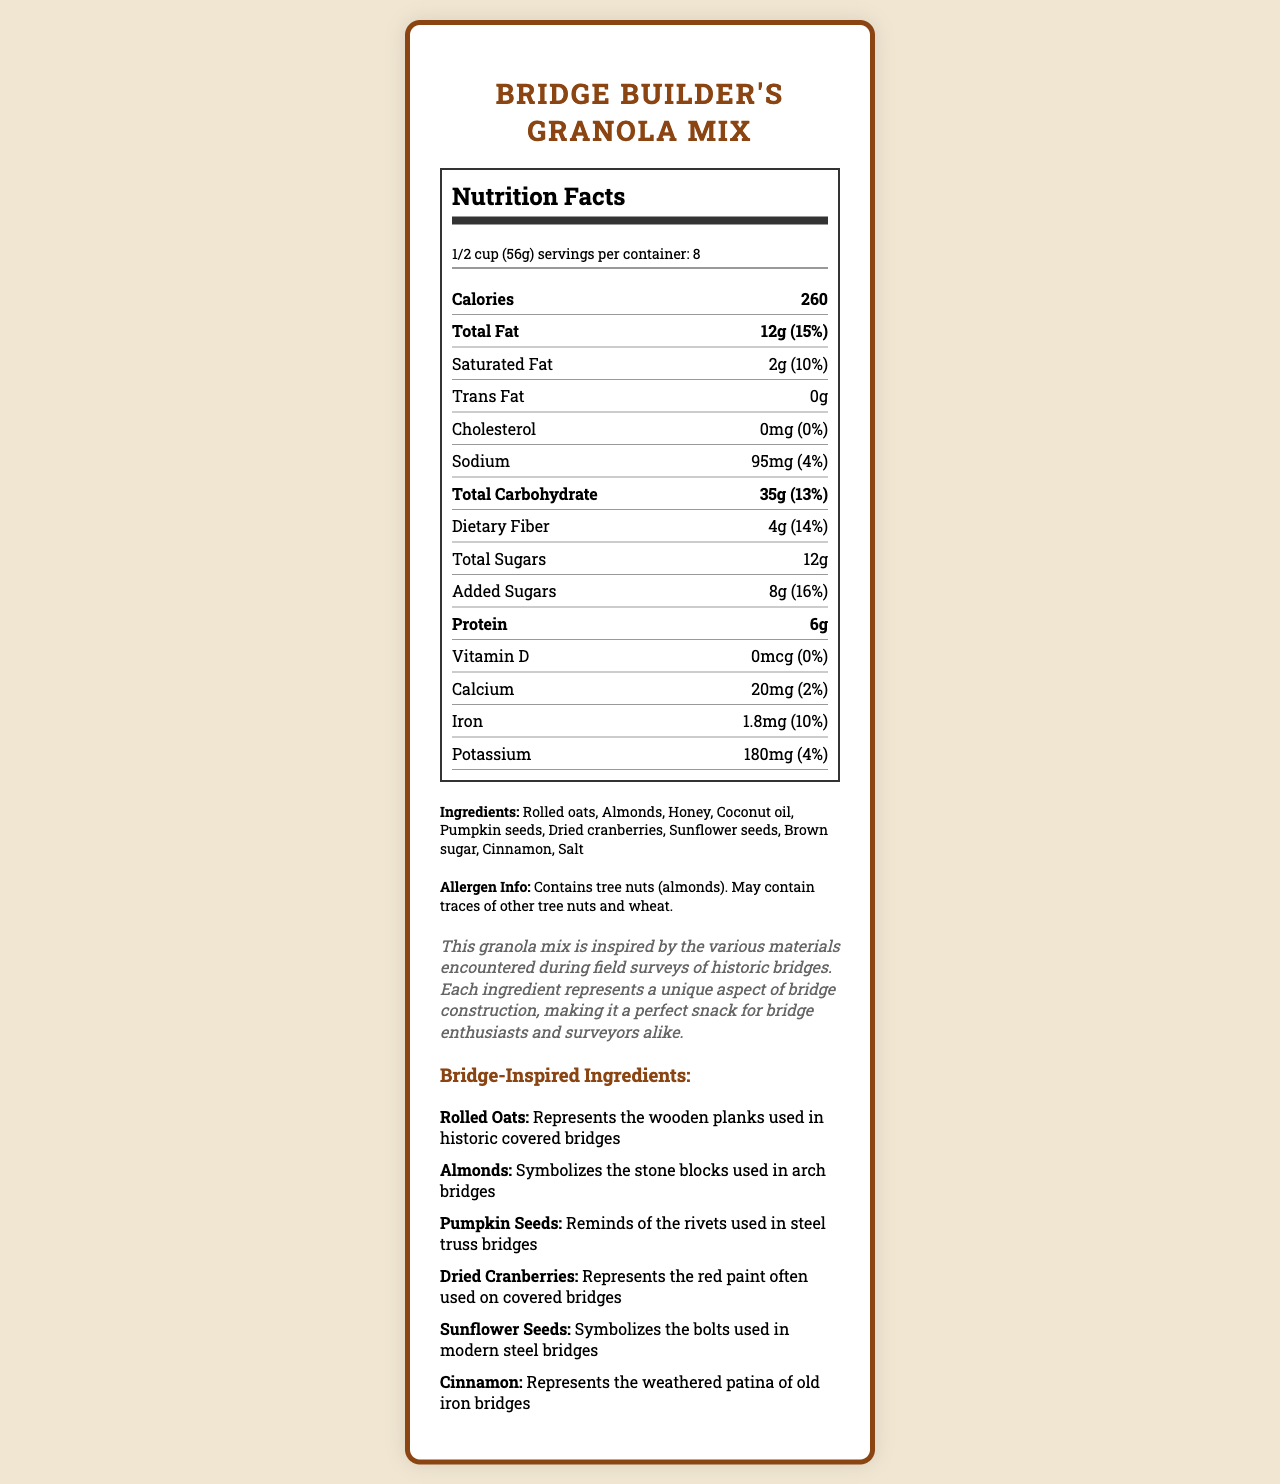what is the serving size for Bridge Builder's Granola Mix? The document states the serving size directly under the product name and serving info section: "1/2 cup (56g)".
Answer: 1/2 cup (56g) how many servings are in the container? The document specifies "servings per container" as 8.
Answer: 8 what ingredient represents the wooden planks used in historic covered bridges? According to the bridge-inspired ingredients section, rolled oats represent the wooden planks used in historic covered bridges.
Answer: Rolled oats how much protein is in one serving of the granola mix? The nutrition label shows "Protein: 6g" under the nutrient section.
Answer: 6g what percentage of the daily value for total fat does one serving of the granola mix provide? The document lists total fat as "12g (15%)".
Answer: 15% how much dietary fiber does the Bridge Builder's Granola Mix contain per serving? The document shows dietary fiber as 4g per serving.
Answer: 4g what specific ingredient symbolizes the stone blocks used in arch bridges? The bridge-inspired ingredients section states that almonds symbolize the stone blocks used in arch bridges.
Answer: Almonds how many milligrams of potassium does one serving of granola mix contain? The nutrition label lists potassium as 180mg per serving.
Answer: 180mg what is the amount of saturated fat per serving and its percentage of daily value? The document lists saturated fat as "2g (10%)".
Answer: 2g, 10% is there any cholesterol in the granola mix? The nutrition label indicates "Cholesterol: 0mg (0%)".
Answer: No what is the granola mix inspired by, according to the bridge surveyor note? The bridge surveyor note explains that each ingredient represents a unique aspect of bridge construction inspired by historic bridges, making it a perfect snack for bridge enthusiasts and surveyors.
Answer: Historic bridges and the materials encountered during field surveys what are the main ingredients used in the Bridge Builder's Granola Mix? These ingredients are listed under the ingredients section.
Answer: Rolled oats, almonds, honey, coconut oil, pumpkin seeds, dried cranberries, sunflower seeds, brown sugar, cinnamon, salt what historical bridge element do pumpkin seeds symbolize? The bridge-inspired ingredients section describes pumpkin seeds as reminding of the rivets used in steel truss bridges.
Answer: Rivets used in steel truss bridges what is the main idea of the document? The document includes detailed nutritional facts, a list of ingredients, allergen information, and an explanation of how each ingredient represents different bridge construction materials.
Answer: The document provides nutritional and ingredient information for Bridge Builder's Granola Mix, a snack inspired by various materials used in historic bridge construction, making it appealing to bridge enthusiasts and surveyors. what percentage of the daily value does calcium contribute per serving? The nutrition label states calcium as "20mg (2%)".
Answer: 2% does the granola mix contain any vitamin D? The document lists vitamin D as "0mcg (0%)".
Answer: No which nutrient has the highest daily value percentage per serving? According to the document, added sugars have the highest daily value percentage per serving at 16%.
Answer: Added sugars with 16% daily value how visually appealing is the layout of the nutrition label? The question asks for subjective feedback and cannot be determined from the available visual information alone.
Answer: Cannot be determined 